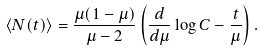Convert formula to latex. <formula><loc_0><loc_0><loc_500><loc_500>\langle N ( t ) \rangle = \frac { \mu ( 1 - \mu ) } { \mu - 2 } \left ( \frac { d } { d \mu } \log C - \frac { t } { \mu } \right ) .</formula> 